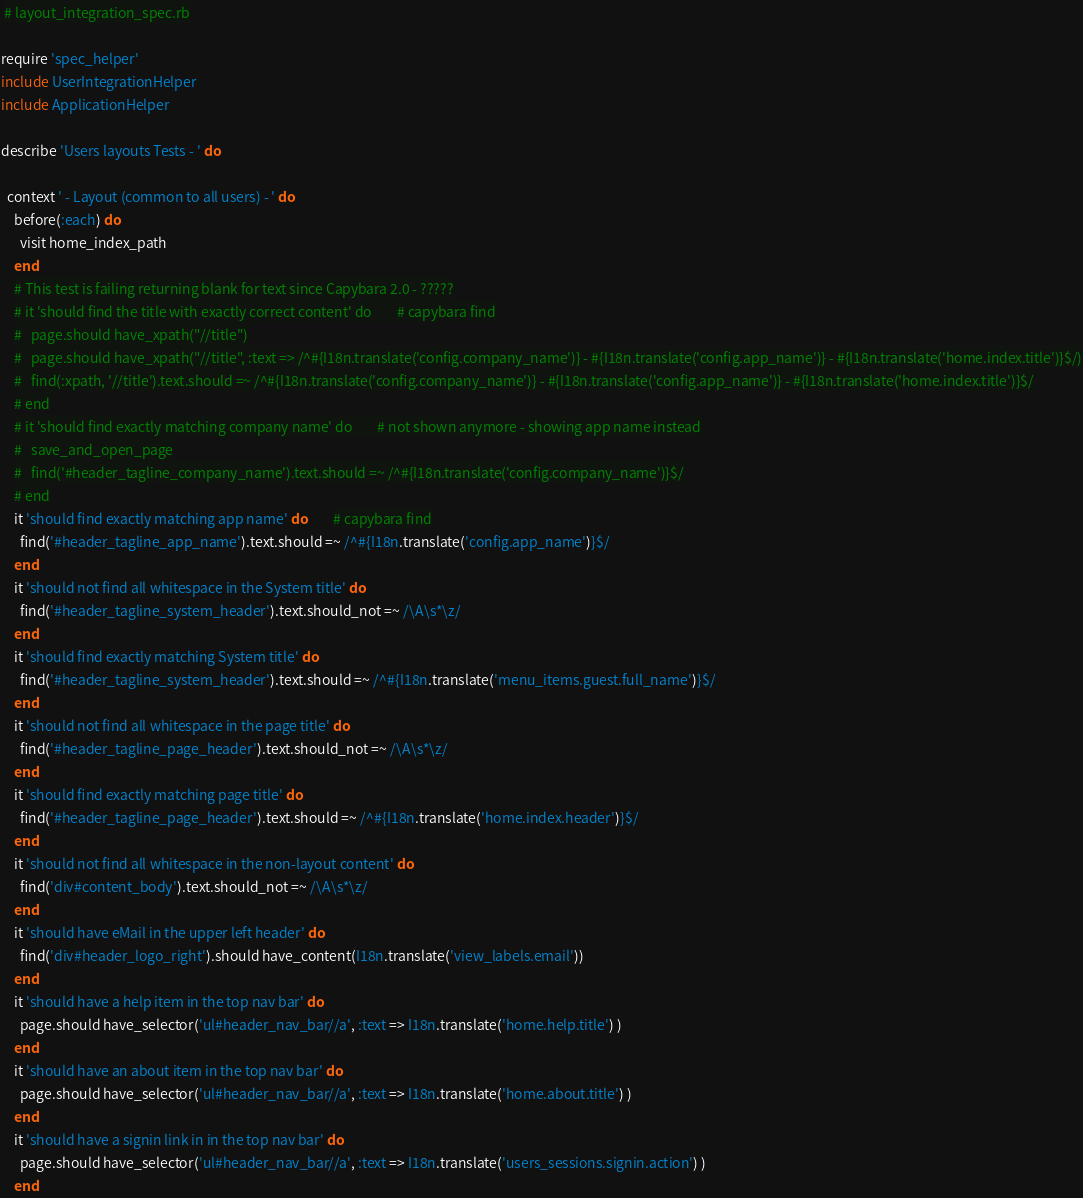<code> <loc_0><loc_0><loc_500><loc_500><_Ruby_> # layout_integration_spec.rb

require 'spec_helper'
include UserIntegrationHelper
include ApplicationHelper

describe 'Users layouts Tests - ' do

  context ' - Layout (common to all users) - ' do
    before(:each) do
      visit home_index_path
    end
    # This test is failing returning blank for text since Capybara 2.0 - ?????
    # it 'should find the title with exactly correct content' do        # capybara find
    #   page.should have_xpath("//title")
    #   page.should have_xpath("//title", :text => /^#{I18n.translate('config.company_name')} - #{I18n.translate('config.app_name')} - #{I18n.translate('home.index.title')}$/)
    #   find(:xpath, '//title').text.should =~ /^#{I18n.translate('config.company_name')} - #{I18n.translate('config.app_name')} - #{I18n.translate('home.index.title')}$/
    # end
    # it 'should find exactly matching company name' do        # not shown anymore - showing app name instead
    #   save_and_open_page
    #   find('#header_tagline_company_name').text.should =~ /^#{I18n.translate('config.company_name')}$/
    # end
    it 'should find exactly matching app name' do        # capybara find
      find('#header_tagline_app_name').text.should =~ /^#{I18n.translate('config.app_name')}$/
    end
    it 'should not find all whitespace in the System title' do
      find('#header_tagline_system_header').text.should_not =~ /\A\s*\z/
    end
    it 'should find exactly matching System title' do
      find('#header_tagline_system_header').text.should =~ /^#{I18n.translate('menu_items.guest.full_name')}$/
    end
    it 'should not find all whitespace in the page title' do
      find('#header_tagline_page_header').text.should_not =~ /\A\s*\z/
    end
    it 'should find exactly matching page title' do
      find('#header_tagline_page_header').text.should =~ /^#{I18n.translate('home.index.header')}$/
    end
    it 'should not find all whitespace in the non-layout content' do
      find('div#content_body').text.should_not =~ /\A\s*\z/
    end
    it 'should have eMail in the upper left header' do
      find('div#header_logo_right').should have_content(I18n.translate('view_labels.email'))
    end
    it 'should have a help item in the top nav bar' do
      page.should have_selector('ul#header_nav_bar//a', :text => I18n.translate('home.help.title') )
    end
    it 'should have an about item in the top nav bar' do
      page.should have_selector('ul#header_nav_bar//a', :text => I18n.translate('home.about.title') )
    end
    it 'should have a signin link in in the top nav bar' do
      page.should have_selector('ul#header_nav_bar//a', :text => I18n.translate('users_sessions.signin.action') )
    end</code> 